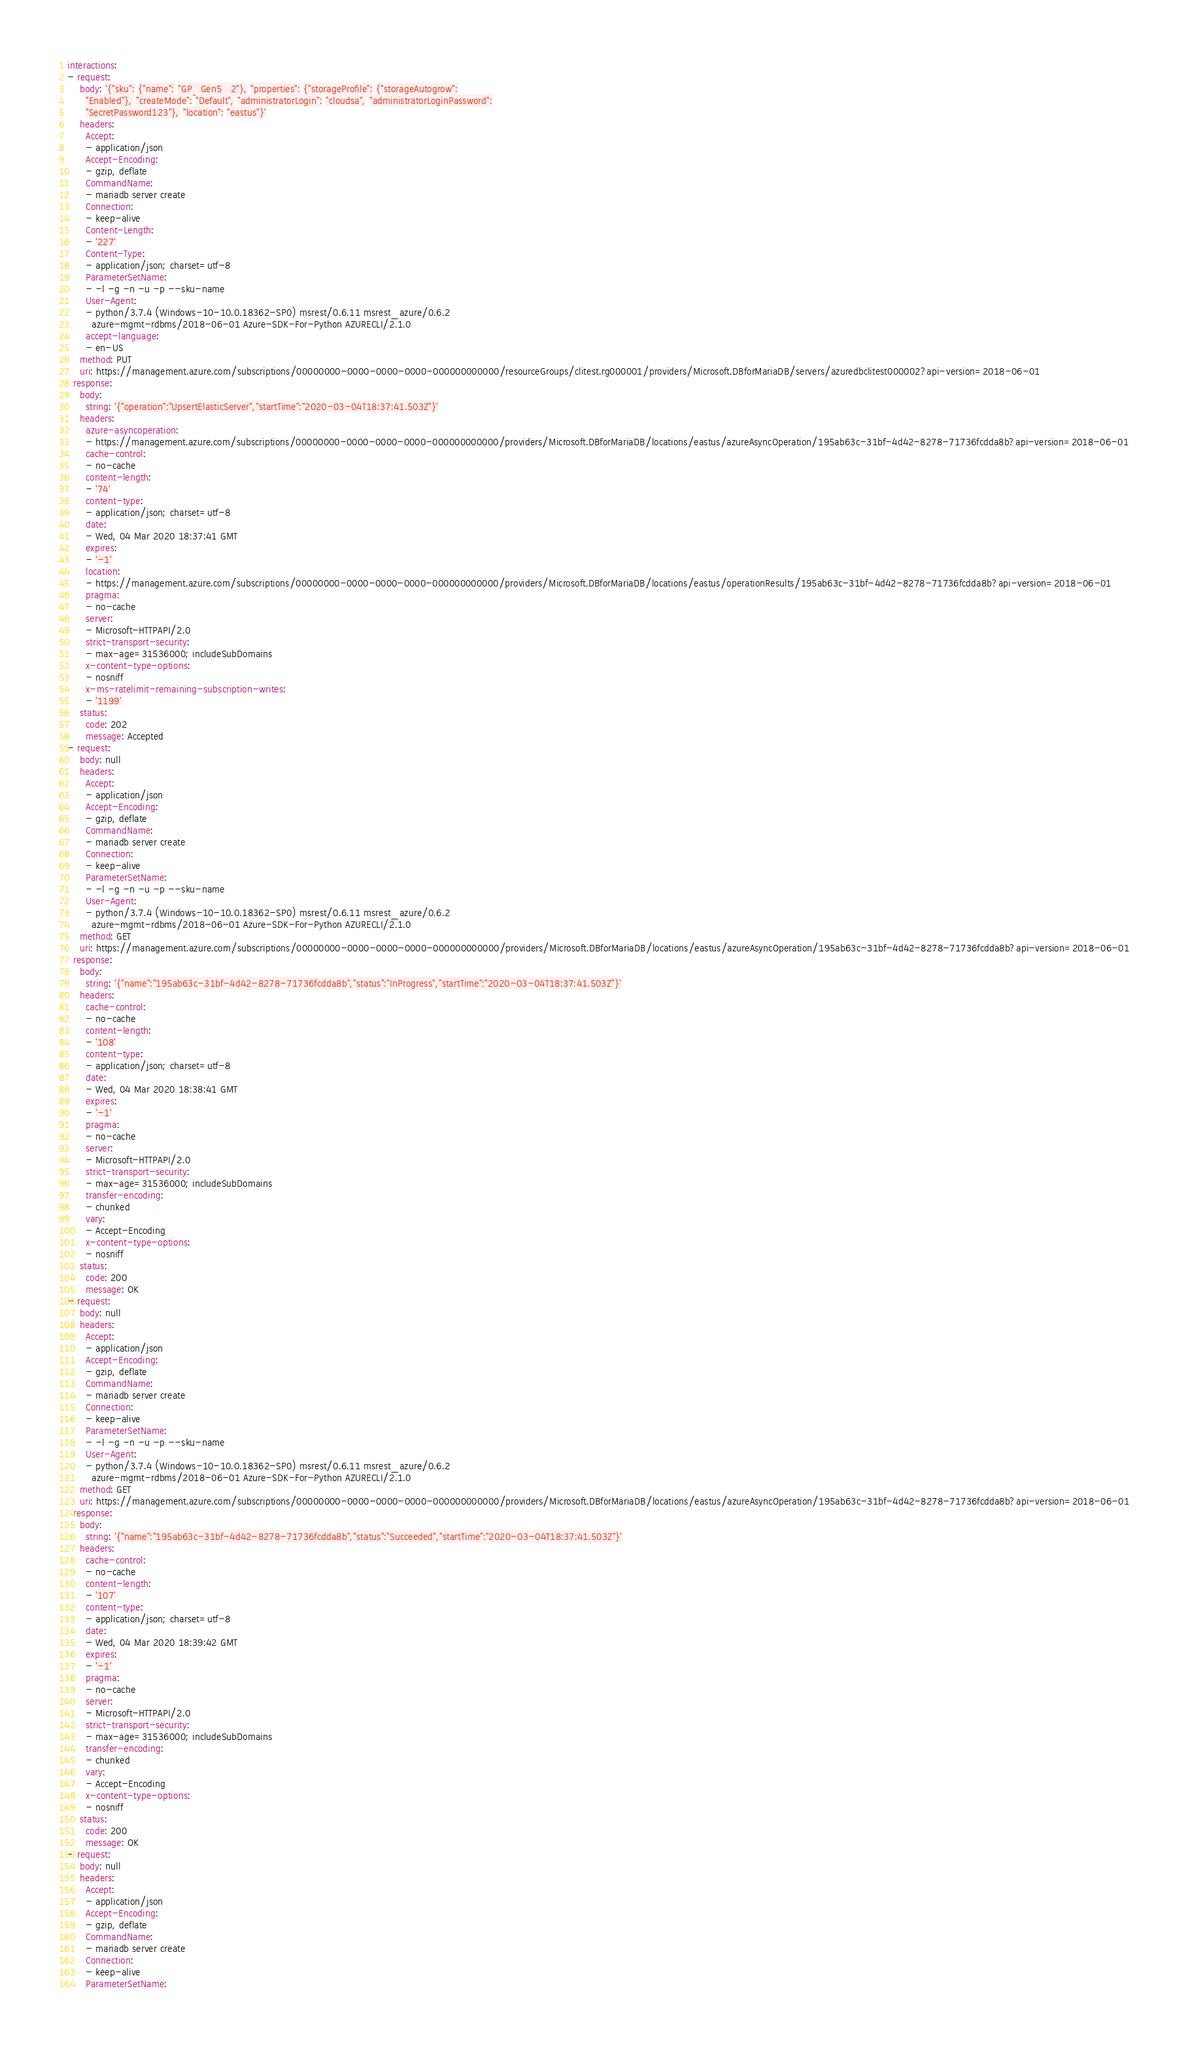Convert code to text. <code><loc_0><loc_0><loc_500><loc_500><_YAML_>interactions:
- request:
    body: '{"sku": {"name": "GP_Gen5_2"}, "properties": {"storageProfile": {"storageAutogrow":
      "Enabled"}, "createMode": "Default", "administratorLogin": "cloudsa", "administratorLoginPassword":
      "SecretPassword123"}, "location": "eastus"}'
    headers:
      Accept:
      - application/json
      Accept-Encoding:
      - gzip, deflate
      CommandName:
      - mariadb server create
      Connection:
      - keep-alive
      Content-Length:
      - '227'
      Content-Type:
      - application/json; charset=utf-8
      ParameterSetName:
      - -l -g -n -u -p --sku-name
      User-Agent:
      - python/3.7.4 (Windows-10-10.0.18362-SP0) msrest/0.6.11 msrest_azure/0.6.2
        azure-mgmt-rdbms/2018-06-01 Azure-SDK-For-Python AZURECLI/2.1.0
      accept-language:
      - en-US
    method: PUT
    uri: https://management.azure.com/subscriptions/00000000-0000-0000-0000-000000000000/resourceGroups/clitest.rg000001/providers/Microsoft.DBforMariaDB/servers/azuredbclitest000002?api-version=2018-06-01
  response:
    body:
      string: '{"operation":"UpsertElasticServer","startTime":"2020-03-04T18:37:41.503Z"}'
    headers:
      azure-asyncoperation:
      - https://management.azure.com/subscriptions/00000000-0000-0000-0000-000000000000/providers/Microsoft.DBforMariaDB/locations/eastus/azureAsyncOperation/195ab63c-31bf-4d42-8278-71736fcdda8b?api-version=2018-06-01
      cache-control:
      - no-cache
      content-length:
      - '74'
      content-type:
      - application/json; charset=utf-8
      date:
      - Wed, 04 Mar 2020 18:37:41 GMT
      expires:
      - '-1'
      location:
      - https://management.azure.com/subscriptions/00000000-0000-0000-0000-000000000000/providers/Microsoft.DBforMariaDB/locations/eastus/operationResults/195ab63c-31bf-4d42-8278-71736fcdda8b?api-version=2018-06-01
      pragma:
      - no-cache
      server:
      - Microsoft-HTTPAPI/2.0
      strict-transport-security:
      - max-age=31536000; includeSubDomains
      x-content-type-options:
      - nosniff
      x-ms-ratelimit-remaining-subscription-writes:
      - '1199'
    status:
      code: 202
      message: Accepted
- request:
    body: null
    headers:
      Accept:
      - application/json
      Accept-Encoding:
      - gzip, deflate
      CommandName:
      - mariadb server create
      Connection:
      - keep-alive
      ParameterSetName:
      - -l -g -n -u -p --sku-name
      User-Agent:
      - python/3.7.4 (Windows-10-10.0.18362-SP0) msrest/0.6.11 msrest_azure/0.6.2
        azure-mgmt-rdbms/2018-06-01 Azure-SDK-For-Python AZURECLI/2.1.0
    method: GET
    uri: https://management.azure.com/subscriptions/00000000-0000-0000-0000-000000000000/providers/Microsoft.DBforMariaDB/locations/eastus/azureAsyncOperation/195ab63c-31bf-4d42-8278-71736fcdda8b?api-version=2018-06-01
  response:
    body:
      string: '{"name":"195ab63c-31bf-4d42-8278-71736fcdda8b","status":"InProgress","startTime":"2020-03-04T18:37:41.503Z"}'
    headers:
      cache-control:
      - no-cache
      content-length:
      - '108'
      content-type:
      - application/json; charset=utf-8
      date:
      - Wed, 04 Mar 2020 18:38:41 GMT
      expires:
      - '-1'
      pragma:
      - no-cache
      server:
      - Microsoft-HTTPAPI/2.0
      strict-transport-security:
      - max-age=31536000; includeSubDomains
      transfer-encoding:
      - chunked
      vary:
      - Accept-Encoding
      x-content-type-options:
      - nosniff
    status:
      code: 200
      message: OK
- request:
    body: null
    headers:
      Accept:
      - application/json
      Accept-Encoding:
      - gzip, deflate
      CommandName:
      - mariadb server create
      Connection:
      - keep-alive
      ParameterSetName:
      - -l -g -n -u -p --sku-name
      User-Agent:
      - python/3.7.4 (Windows-10-10.0.18362-SP0) msrest/0.6.11 msrest_azure/0.6.2
        azure-mgmt-rdbms/2018-06-01 Azure-SDK-For-Python AZURECLI/2.1.0
    method: GET
    uri: https://management.azure.com/subscriptions/00000000-0000-0000-0000-000000000000/providers/Microsoft.DBforMariaDB/locations/eastus/azureAsyncOperation/195ab63c-31bf-4d42-8278-71736fcdda8b?api-version=2018-06-01
  response:
    body:
      string: '{"name":"195ab63c-31bf-4d42-8278-71736fcdda8b","status":"Succeeded","startTime":"2020-03-04T18:37:41.503Z"}'
    headers:
      cache-control:
      - no-cache
      content-length:
      - '107'
      content-type:
      - application/json; charset=utf-8
      date:
      - Wed, 04 Mar 2020 18:39:42 GMT
      expires:
      - '-1'
      pragma:
      - no-cache
      server:
      - Microsoft-HTTPAPI/2.0
      strict-transport-security:
      - max-age=31536000; includeSubDomains
      transfer-encoding:
      - chunked
      vary:
      - Accept-Encoding
      x-content-type-options:
      - nosniff
    status:
      code: 200
      message: OK
- request:
    body: null
    headers:
      Accept:
      - application/json
      Accept-Encoding:
      - gzip, deflate
      CommandName:
      - mariadb server create
      Connection:
      - keep-alive
      ParameterSetName:</code> 